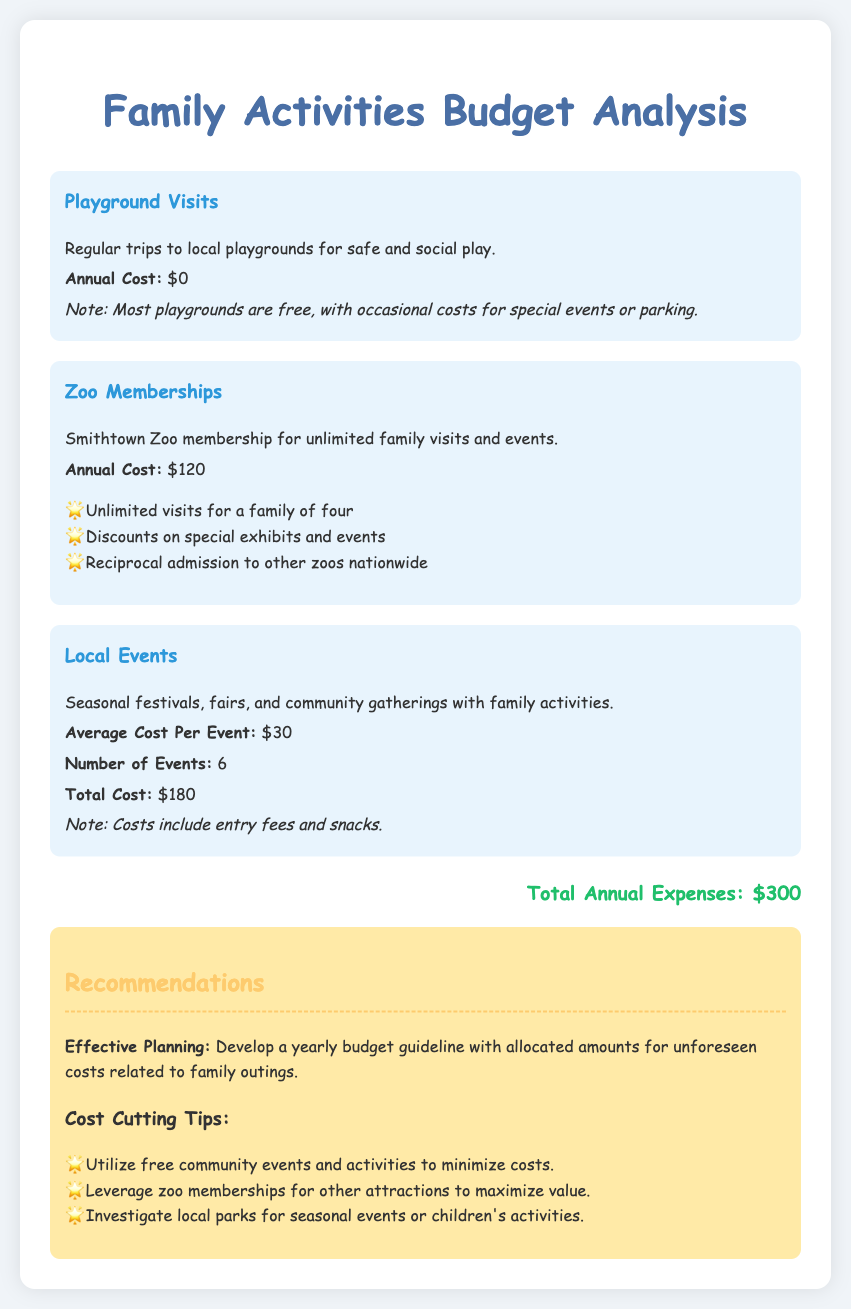what is the cost of zoo memberships? The zoo membership cost is listed as the annual expense for the family, which is $120.
Answer: $120 how many playground visits are included in the budget? The document states that regular playground visits have no associated cost. Hence, it indicates zero costs annually.
Answer: $0 what is the average cost per local event? The document specifies the average cost per local event as a set amount, which is $30.
Answer: $30 how many local events are planned for the year? The report mentions the number of local events that the family intends to attend as six.
Answer: 6 what is the total annual expense for family activities? The total annual expenses for all activities, including playground visits, zoo memberships, and local events, provides a conclusive budget, which is $300.
Answer: $300 what type of activities are included in playground visits? The document describes the nature of playground visits, stating they involve safe and social play at local playgrounds.
Answer: Safe and social play how can the family maximize value from their zoo membership? The document suggests leveraging zoo memberships for other attractions to maximize value, highlighting a strategy for better utilization.
Answer: Leverage zoo memberships what recommendations are provided for effective planning? The report recommends developing a yearly budget guideline to account for unforeseen costs related to family outings.
Answer: Develop a yearly budget guideline 